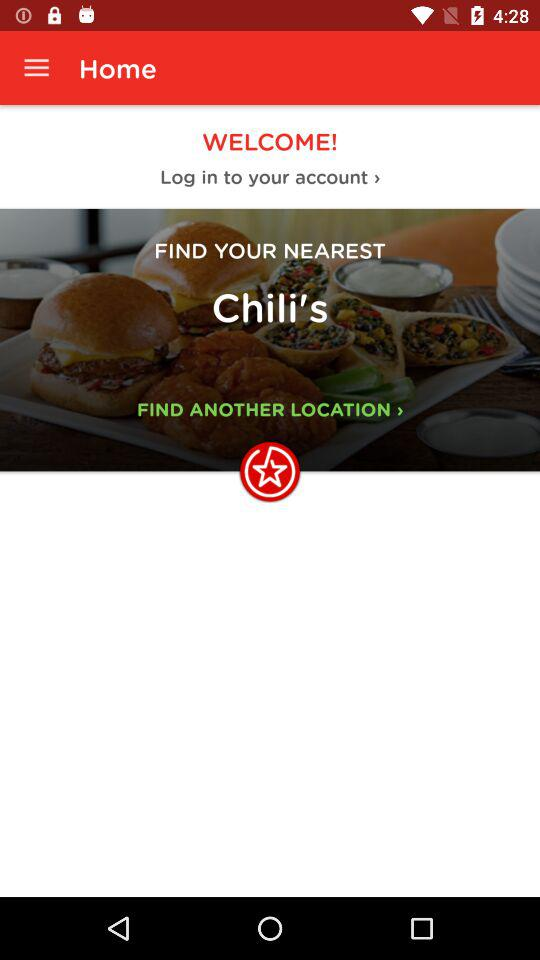Where is the nearest Chili's?
When the provided information is insufficient, respond with <no answer>. <no answer> 